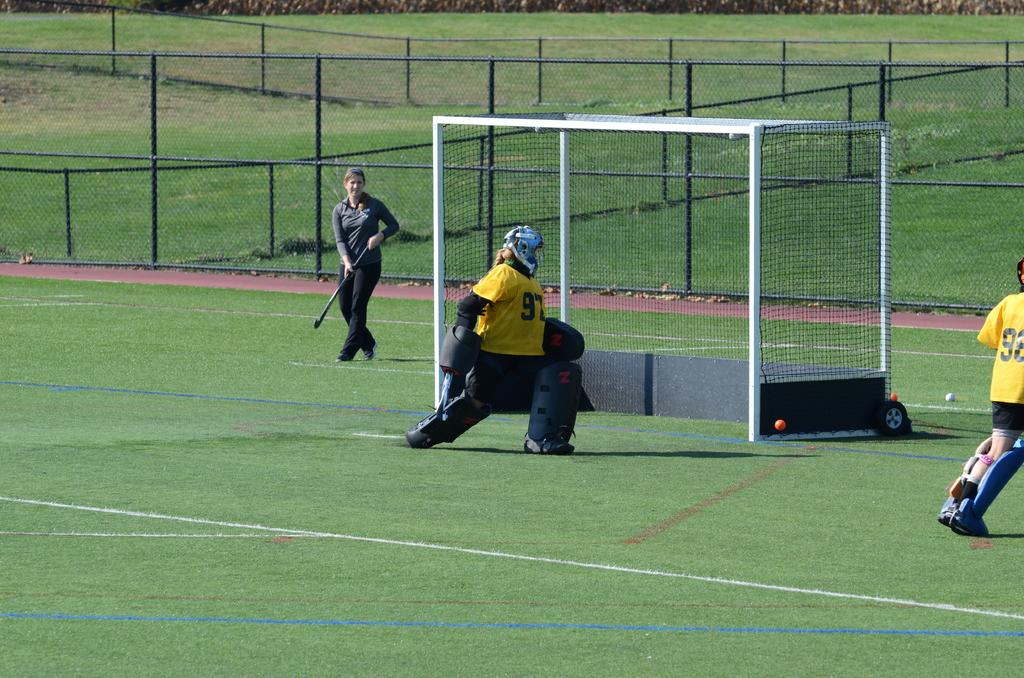<image>
Render a clear and concise summary of the photo. A goalie is number 97 in a soccer game. 